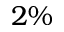<formula> <loc_0><loc_0><loc_500><loc_500>2 \%</formula> 